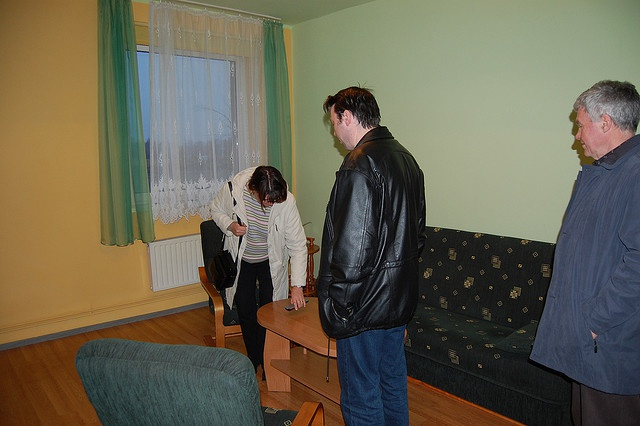Describe the objects in this image and their specific colors. I can see people in olive, black, navy, gray, and darkblue tones, people in olive, gray, darkblue, and black tones, couch in olive, black, darkgreen, and gray tones, couch in olive, teal, purple, and black tones, and people in olive, darkgray, black, and gray tones in this image. 